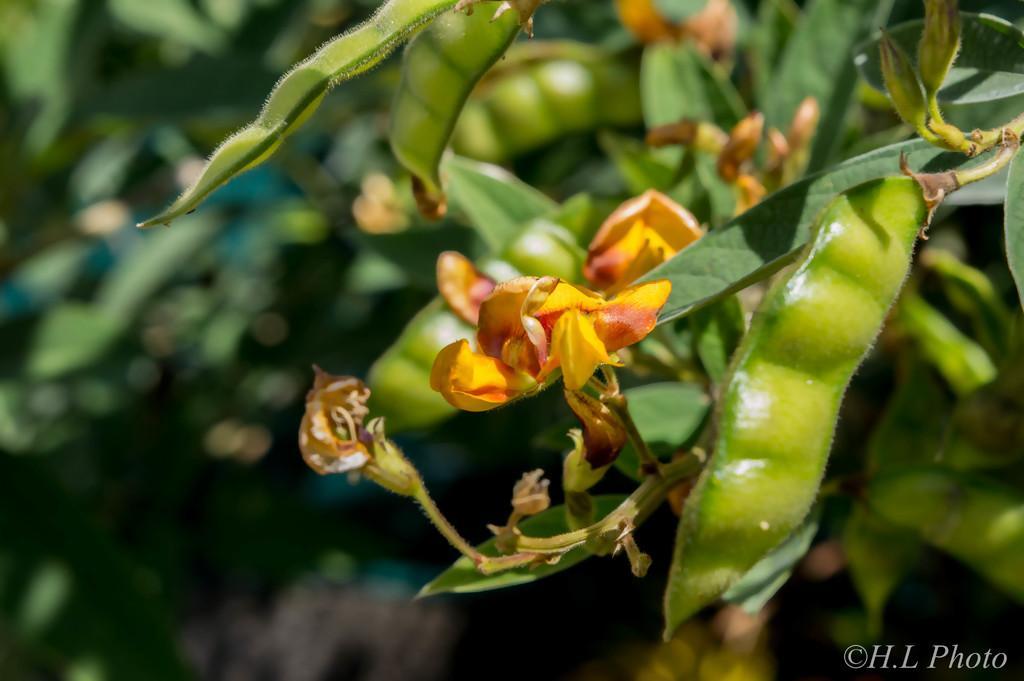How would you summarize this image in a sentence or two? In this image we can see a beans tree, here is the flower, at background it is blurry. 